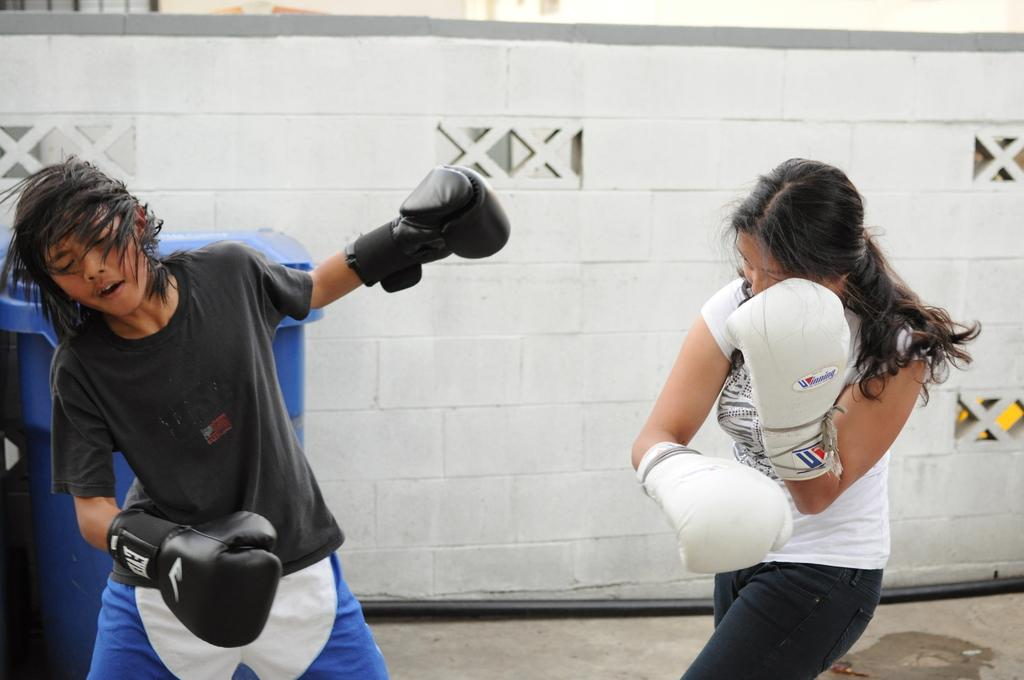How many people are in the image? There are two people in the image, a girl and a boy. What are the girl and the boy wearing? They are both wearing boxing gloves. What activity are they engaged in? They appear to be fighting. What can be seen in the background of the image? There is a drum and a wall in the background of the image. What news is the girl sharing with the boy in the image? There is no indication in the image that the girl is sharing any news with the boy. 